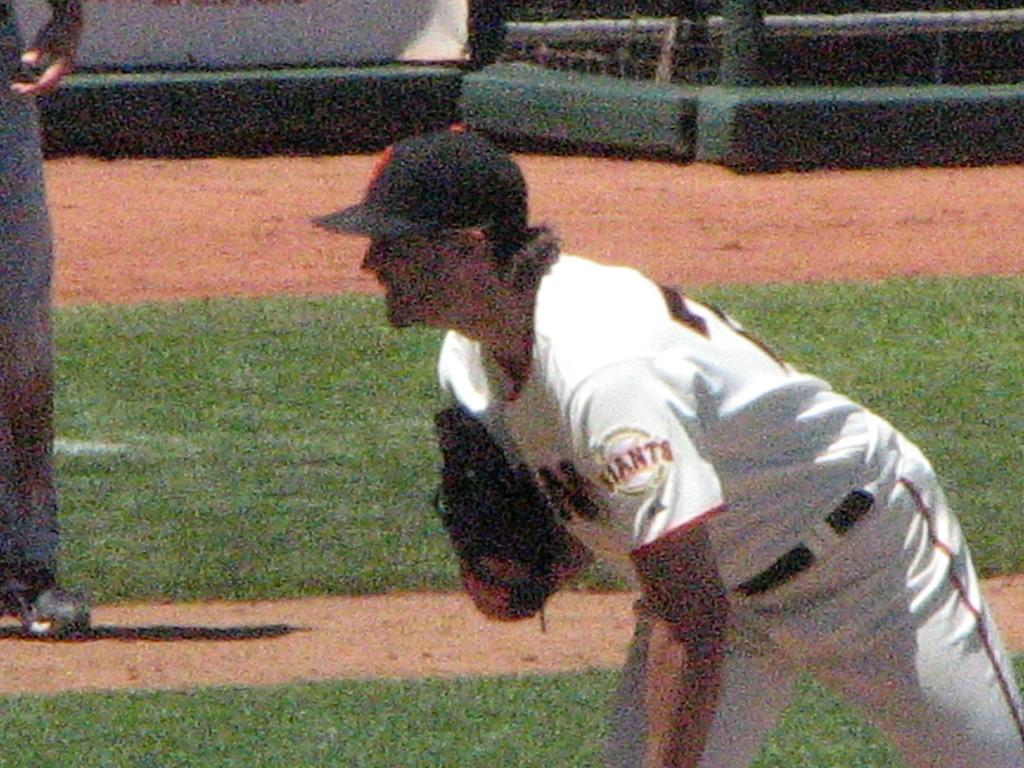<image>
Write a terse but informative summary of the picture. A Giants player is leaning forward, ready for the play. 